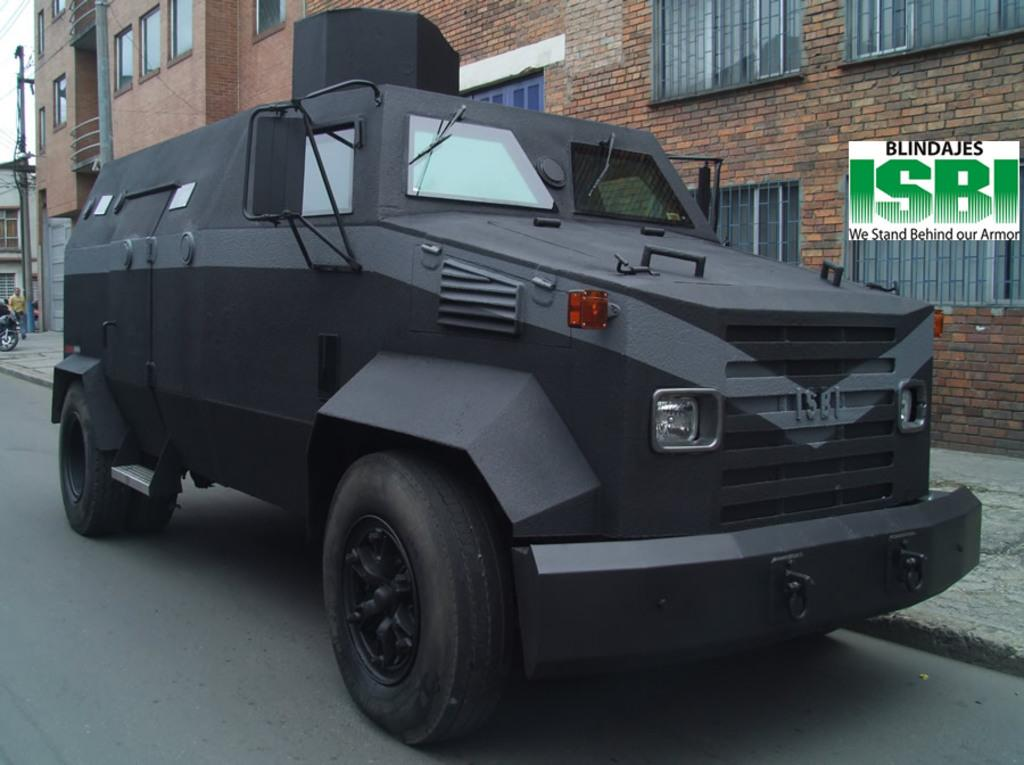What is the main subject of the image? There is a vehicle on the road in the image. Can you describe another vehicle in the image? Yes, there is another vehicle on the pathway in the image. What else can be seen in the image besides vehicles? There is a person standing in the image, as well as buildings. Is there any additional information about the image itself? Yes, there is a watermark on the image. How does the person in the image give birth to a new vehicle? The person in the image is not giving birth to a new vehicle, as there is no indication of such an event in the image. 